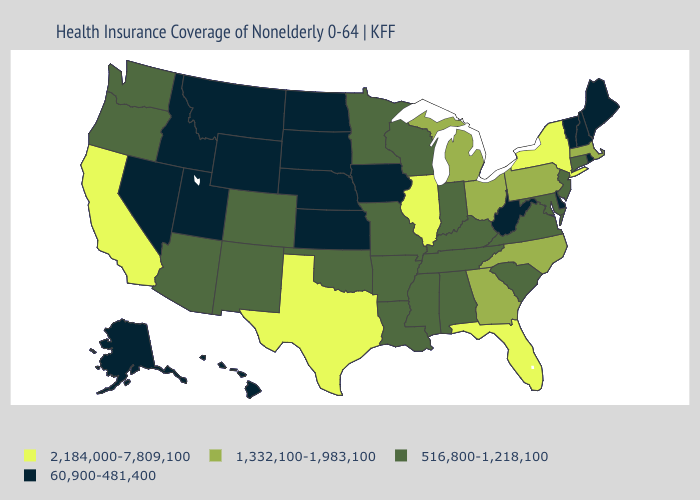Name the states that have a value in the range 1,332,100-1,983,100?
Quick response, please. Georgia, Massachusetts, Michigan, North Carolina, Ohio, Pennsylvania. Name the states that have a value in the range 2,184,000-7,809,100?
Keep it brief. California, Florida, Illinois, New York, Texas. Is the legend a continuous bar?
Keep it brief. No. What is the value of Indiana?
Answer briefly. 516,800-1,218,100. Which states hav the highest value in the Northeast?
Short answer required. New York. Name the states that have a value in the range 60,900-481,400?
Be succinct. Alaska, Delaware, Hawaii, Idaho, Iowa, Kansas, Maine, Montana, Nebraska, Nevada, New Hampshire, North Dakota, Rhode Island, South Dakota, Utah, Vermont, West Virginia, Wyoming. Name the states that have a value in the range 1,332,100-1,983,100?
Answer briefly. Georgia, Massachusetts, Michigan, North Carolina, Ohio, Pennsylvania. Which states have the lowest value in the MidWest?
Keep it brief. Iowa, Kansas, Nebraska, North Dakota, South Dakota. Among the states that border Kansas , which have the highest value?
Concise answer only. Colorado, Missouri, Oklahoma. What is the highest value in states that border Virginia?
Give a very brief answer. 1,332,100-1,983,100. What is the highest value in the USA?
Concise answer only. 2,184,000-7,809,100. What is the highest value in the Northeast ?
Quick response, please. 2,184,000-7,809,100. Among the states that border Montana , which have the highest value?
Be succinct. Idaho, North Dakota, South Dakota, Wyoming. How many symbols are there in the legend?
Keep it brief. 4. Among the states that border Utah , does Idaho have the lowest value?
Short answer required. Yes. 